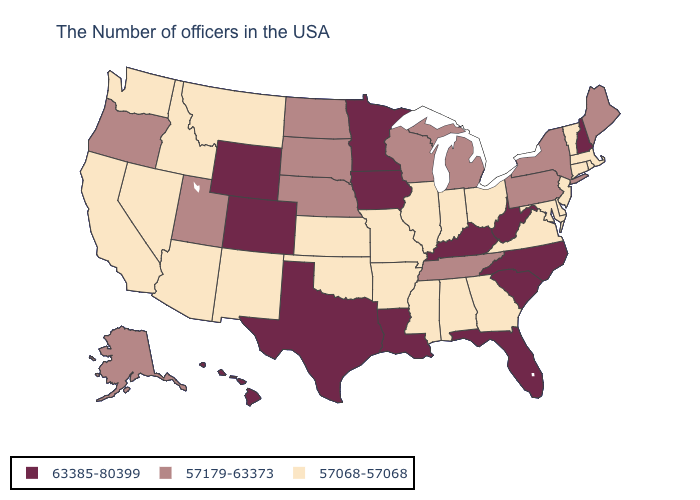What is the value of California?
Quick response, please. 57068-57068. Name the states that have a value in the range 57068-57068?
Be succinct. Massachusetts, Rhode Island, Vermont, Connecticut, New Jersey, Delaware, Maryland, Virginia, Ohio, Georgia, Indiana, Alabama, Illinois, Mississippi, Missouri, Arkansas, Kansas, Oklahoma, New Mexico, Montana, Arizona, Idaho, Nevada, California, Washington. How many symbols are there in the legend?
Write a very short answer. 3. Among the states that border Kentucky , does Ohio have the lowest value?
Short answer required. Yes. Among the states that border Connecticut , does Massachusetts have the highest value?
Concise answer only. No. Name the states that have a value in the range 57068-57068?
Answer briefly. Massachusetts, Rhode Island, Vermont, Connecticut, New Jersey, Delaware, Maryland, Virginia, Ohio, Georgia, Indiana, Alabama, Illinois, Mississippi, Missouri, Arkansas, Kansas, Oklahoma, New Mexico, Montana, Arizona, Idaho, Nevada, California, Washington. Name the states that have a value in the range 57068-57068?
Keep it brief. Massachusetts, Rhode Island, Vermont, Connecticut, New Jersey, Delaware, Maryland, Virginia, Ohio, Georgia, Indiana, Alabama, Illinois, Mississippi, Missouri, Arkansas, Kansas, Oklahoma, New Mexico, Montana, Arizona, Idaho, Nevada, California, Washington. What is the highest value in the USA?
Give a very brief answer. 63385-80399. Name the states that have a value in the range 57068-57068?
Short answer required. Massachusetts, Rhode Island, Vermont, Connecticut, New Jersey, Delaware, Maryland, Virginia, Ohio, Georgia, Indiana, Alabama, Illinois, Mississippi, Missouri, Arkansas, Kansas, Oklahoma, New Mexico, Montana, Arizona, Idaho, Nevada, California, Washington. Name the states that have a value in the range 57068-57068?
Be succinct. Massachusetts, Rhode Island, Vermont, Connecticut, New Jersey, Delaware, Maryland, Virginia, Ohio, Georgia, Indiana, Alabama, Illinois, Mississippi, Missouri, Arkansas, Kansas, Oklahoma, New Mexico, Montana, Arizona, Idaho, Nevada, California, Washington. Name the states that have a value in the range 57068-57068?
Be succinct. Massachusetts, Rhode Island, Vermont, Connecticut, New Jersey, Delaware, Maryland, Virginia, Ohio, Georgia, Indiana, Alabama, Illinois, Mississippi, Missouri, Arkansas, Kansas, Oklahoma, New Mexico, Montana, Arizona, Idaho, Nevada, California, Washington. Is the legend a continuous bar?
Answer briefly. No. What is the highest value in states that border Kansas?
Short answer required. 63385-80399. What is the lowest value in the MidWest?
Short answer required. 57068-57068. Name the states that have a value in the range 63385-80399?
Keep it brief. New Hampshire, North Carolina, South Carolina, West Virginia, Florida, Kentucky, Louisiana, Minnesota, Iowa, Texas, Wyoming, Colorado, Hawaii. 